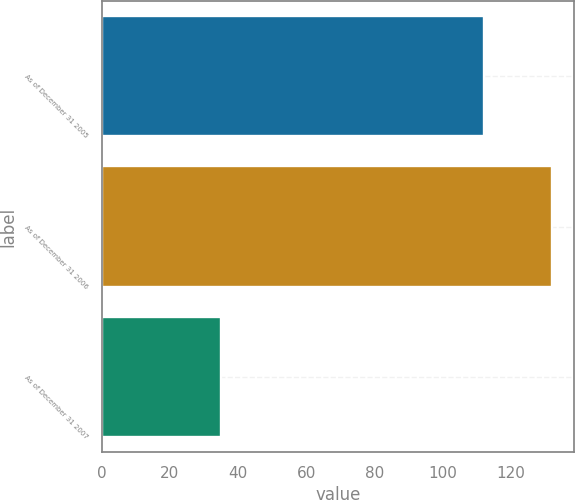Convert chart to OTSL. <chart><loc_0><loc_0><loc_500><loc_500><bar_chart><fcel>As of December 31 2005<fcel>As of December 31 2006<fcel>As of December 31 2007<nl><fcel>112<fcel>132<fcel>35<nl></chart> 